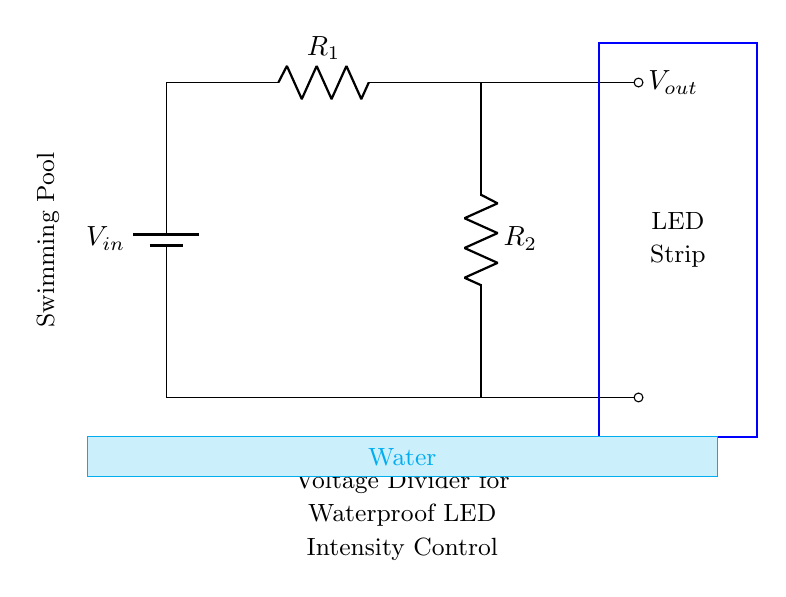What type of circuit is this? This circuit is a voltage divider, which consists of two resistors connected in series. The purpose is to divide the input voltage into a lower output voltage.
Answer: Voltage divider What are the two resistors in the circuit? The resistors in the circuit are labeled as R1 and R2, which determine the output voltage based on their resistance values.
Answer: R1 and R2 What is the purpose of the LED strip in the circuit? The LED strip is used for illumination, and its intensity can be adjusted using the voltage divider setup, allowing for control over the brightness of the waterproof LED lighting.
Answer: Illumination What is the output voltage connected to? The output voltage, labeled Vout, is connected to the LED strip, providing it with the necessary adjusted voltage for operation.
Answer: LED strip How does the output voltage relate to the input voltage? The output voltage is a fraction of the input voltage, calculated based on the values of R1 and R2 using the voltage divider formula Vout = Vin * (R2 / (R1 + R2)).
Answer: Fraction What is the significance of the water indicated in the circuit diagram? The water indicates that the circuit is designed for use in swimming pools, highlighting the need for waterproof components to ensure safety and proper functioning in wet conditions.
Answer: Waterproof What happens to the intensity of the LED lighting when R1 is increased? Increasing R1 will decrease the output voltage (Vout) since the ratio of the resistances will change, resulting in dimmer LED lighting.
Answer: Dimmer lighting 